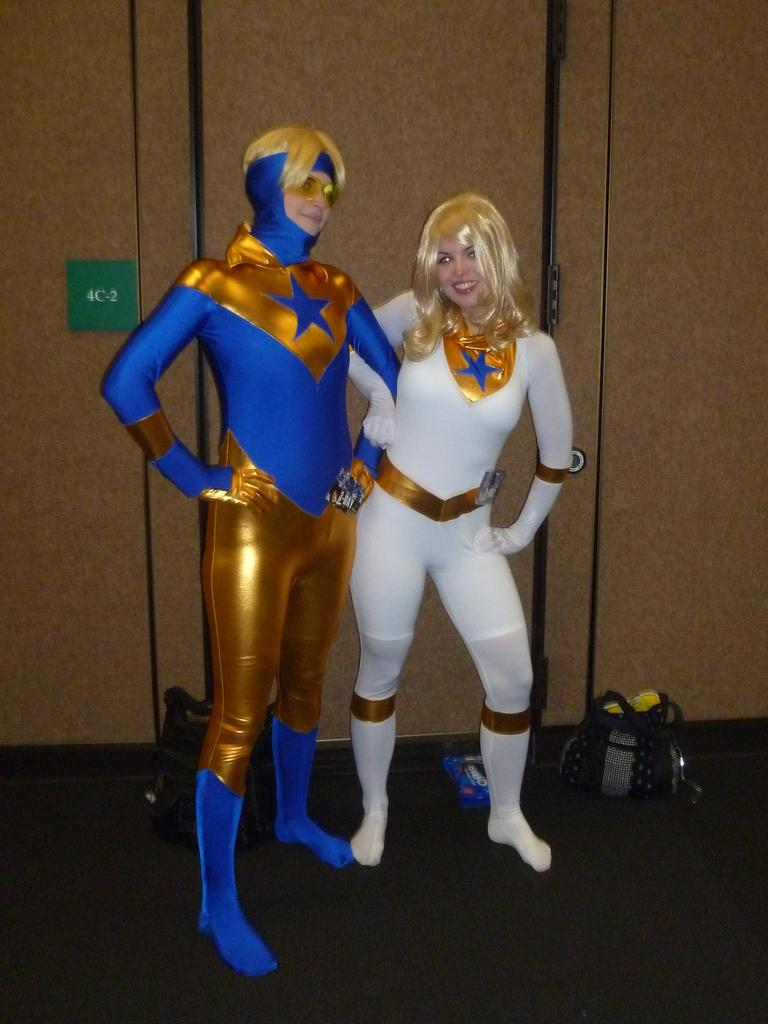How many people are in the image? There are two persons in the image. What are the persons wearing? The persons are wearing costumes. What can be seen in the background of the image? There is a wall in the background of the image. What objects are on the floor in the image? There are bags on the floor in the image. What type of seeds can be seen growing on the costumes of the persons in the image? There are no seeds visible on the costumes of the persons in the image. 